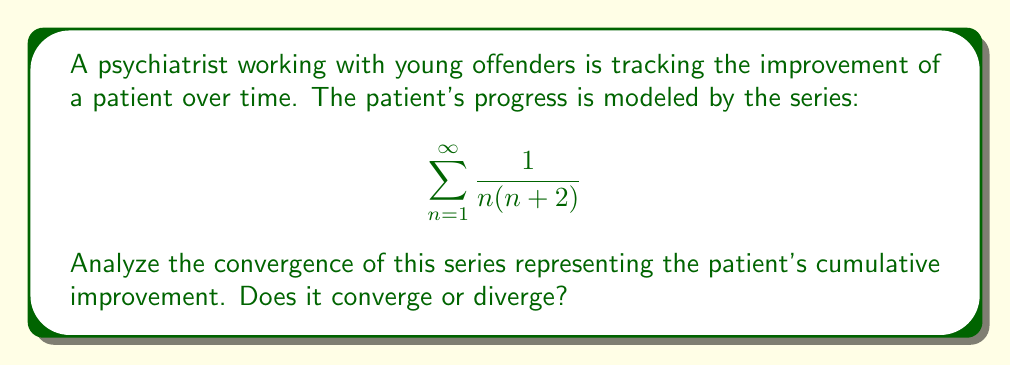Give your solution to this math problem. To analyze the convergence of this series, we can use the limit comparison test with a known series.

Step 1: Choose a comparison series
Let's compare our series to the p-series $\sum_{n=1}^{\infty} \frac{1}{n^2}$, which is known to converge.

Step 2: Set up the limit
$$\lim_{n \to \infty} \frac{a_n}{b_n} = \lim_{n \to \infty} \frac{\frac{1}{n(n+2)}}{\frac{1}{n^2}}$$

Step 3: Simplify the fraction
$$\lim_{n \to \infty} \frac{n^2}{n(n+2)} = \lim_{n \to \infty} \frac{n}{n+2}$$

Step 4: Evaluate the limit
$$\lim_{n \to \infty} \frac{n}{n+2} = \lim_{n \to \infty} \frac{1}{1+\frac{2}{n}} = 1$$

Step 5: Apply the limit comparison test
Since the limit exists and is positive (1), our series converges if and only if the comparison series converges. We know that $\sum_{n=1}^{\infty} \frac{1}{n^2}$ converges.

Therefore, the original series $\sum_{n=1}^{\infty} \frac{1}{n(n+2)}$ also converges.
Answer: Converges 